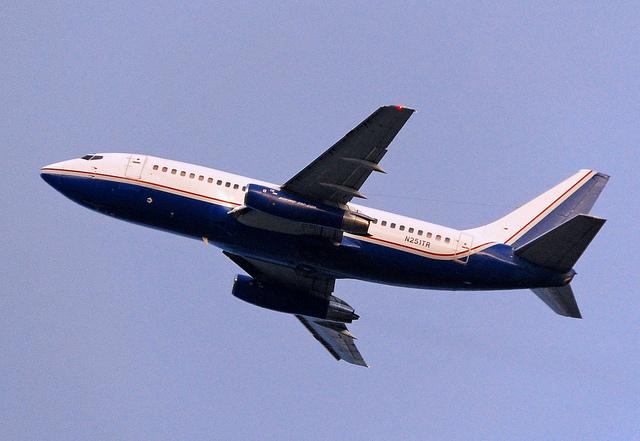Is this a big airplane?
Quick response, please. Yes. Are there wheels in the picture?
Quick response, please. No. Does this plane have its landing gear down?
Be succinct. No. What is this?
Be succinct. Airplane. Does the plane have windows?
Be succinct. Yes. 